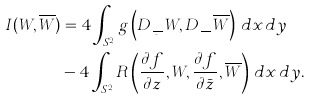Convert formula to latex. <formula><loc_0><loc_0><loc_500><loc_500>I ( W , \overline { W } ) & = 4 \int _ { S ^ { 2 } } g \left ( D _ { \frac { \partial } { \partial \bar { z } } } W , D _ { \frac { \partial } { \partial z } } \overline { W } \right ) \, d x \, d y \\ & - 4 \int _ { S ^ { 2 } } R \left ( \frac { \partial f } { \partial z } , W , \frac { \partial f } { \partial \bar { z } } , \overline { W } \right ) \, d x \, d y .</formula> 